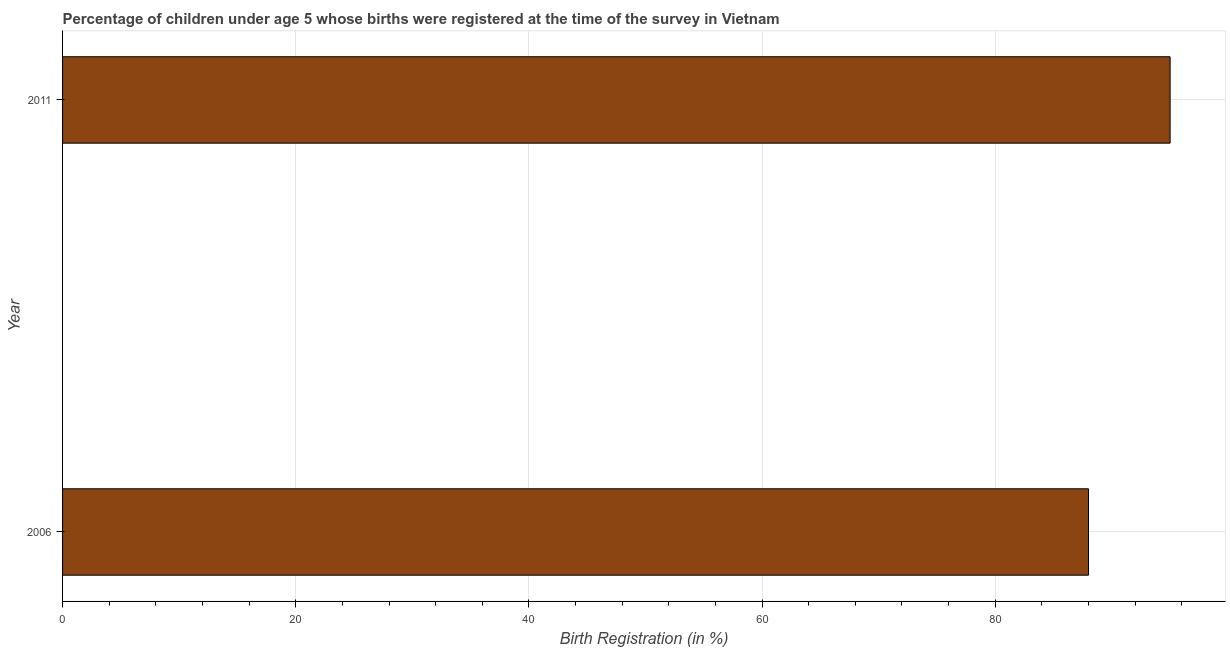Does the graph contain any zero values?
Offer a terse response. No. Does the graph contain grids?
Your answer should be compact. Yes. What is the title of the graph?
Keep it short and to the point. Percentage of children under age 5 whose births were registered at the time of the survey in Vietnam. What is the label or title of the X-axis?
Provide a succinct answer. Birth Registration (in %). What is the label or title of the Y-axis?
Make the answer very short. Year. What is the birth registration in 2006?
Ensure brevity in your answer.  88. Across all years, what is the maximum birth registration?
Your answer should be very brief. 95. What is the sum of the birth registration?
Ensure brevity in your answer.  183. What is the average birth registration per year?
Your response must be concise. 91. What is the median birth registration?
Ensure brevity in your answer.  91.5. What is the ratio of the birth registration in 2006 to that in 2011?
Provide a short and direct response. 0.93. Is the birth registration in 2006 less than that in 2011?
Provide a short and direct response. Yes. How many bars are there?
Your answer should be compact. 2. Are all the bars in the graph horizontal?
Ensure brevity in your answer.  Yes. What is the difference between two consecutive major ticks on the X-axis?
Your response must be concise. 20. What is the ratio of the Birth Registration (in %) in 2006 to that in 2011?
Keep it short and to the point. 0.93. 